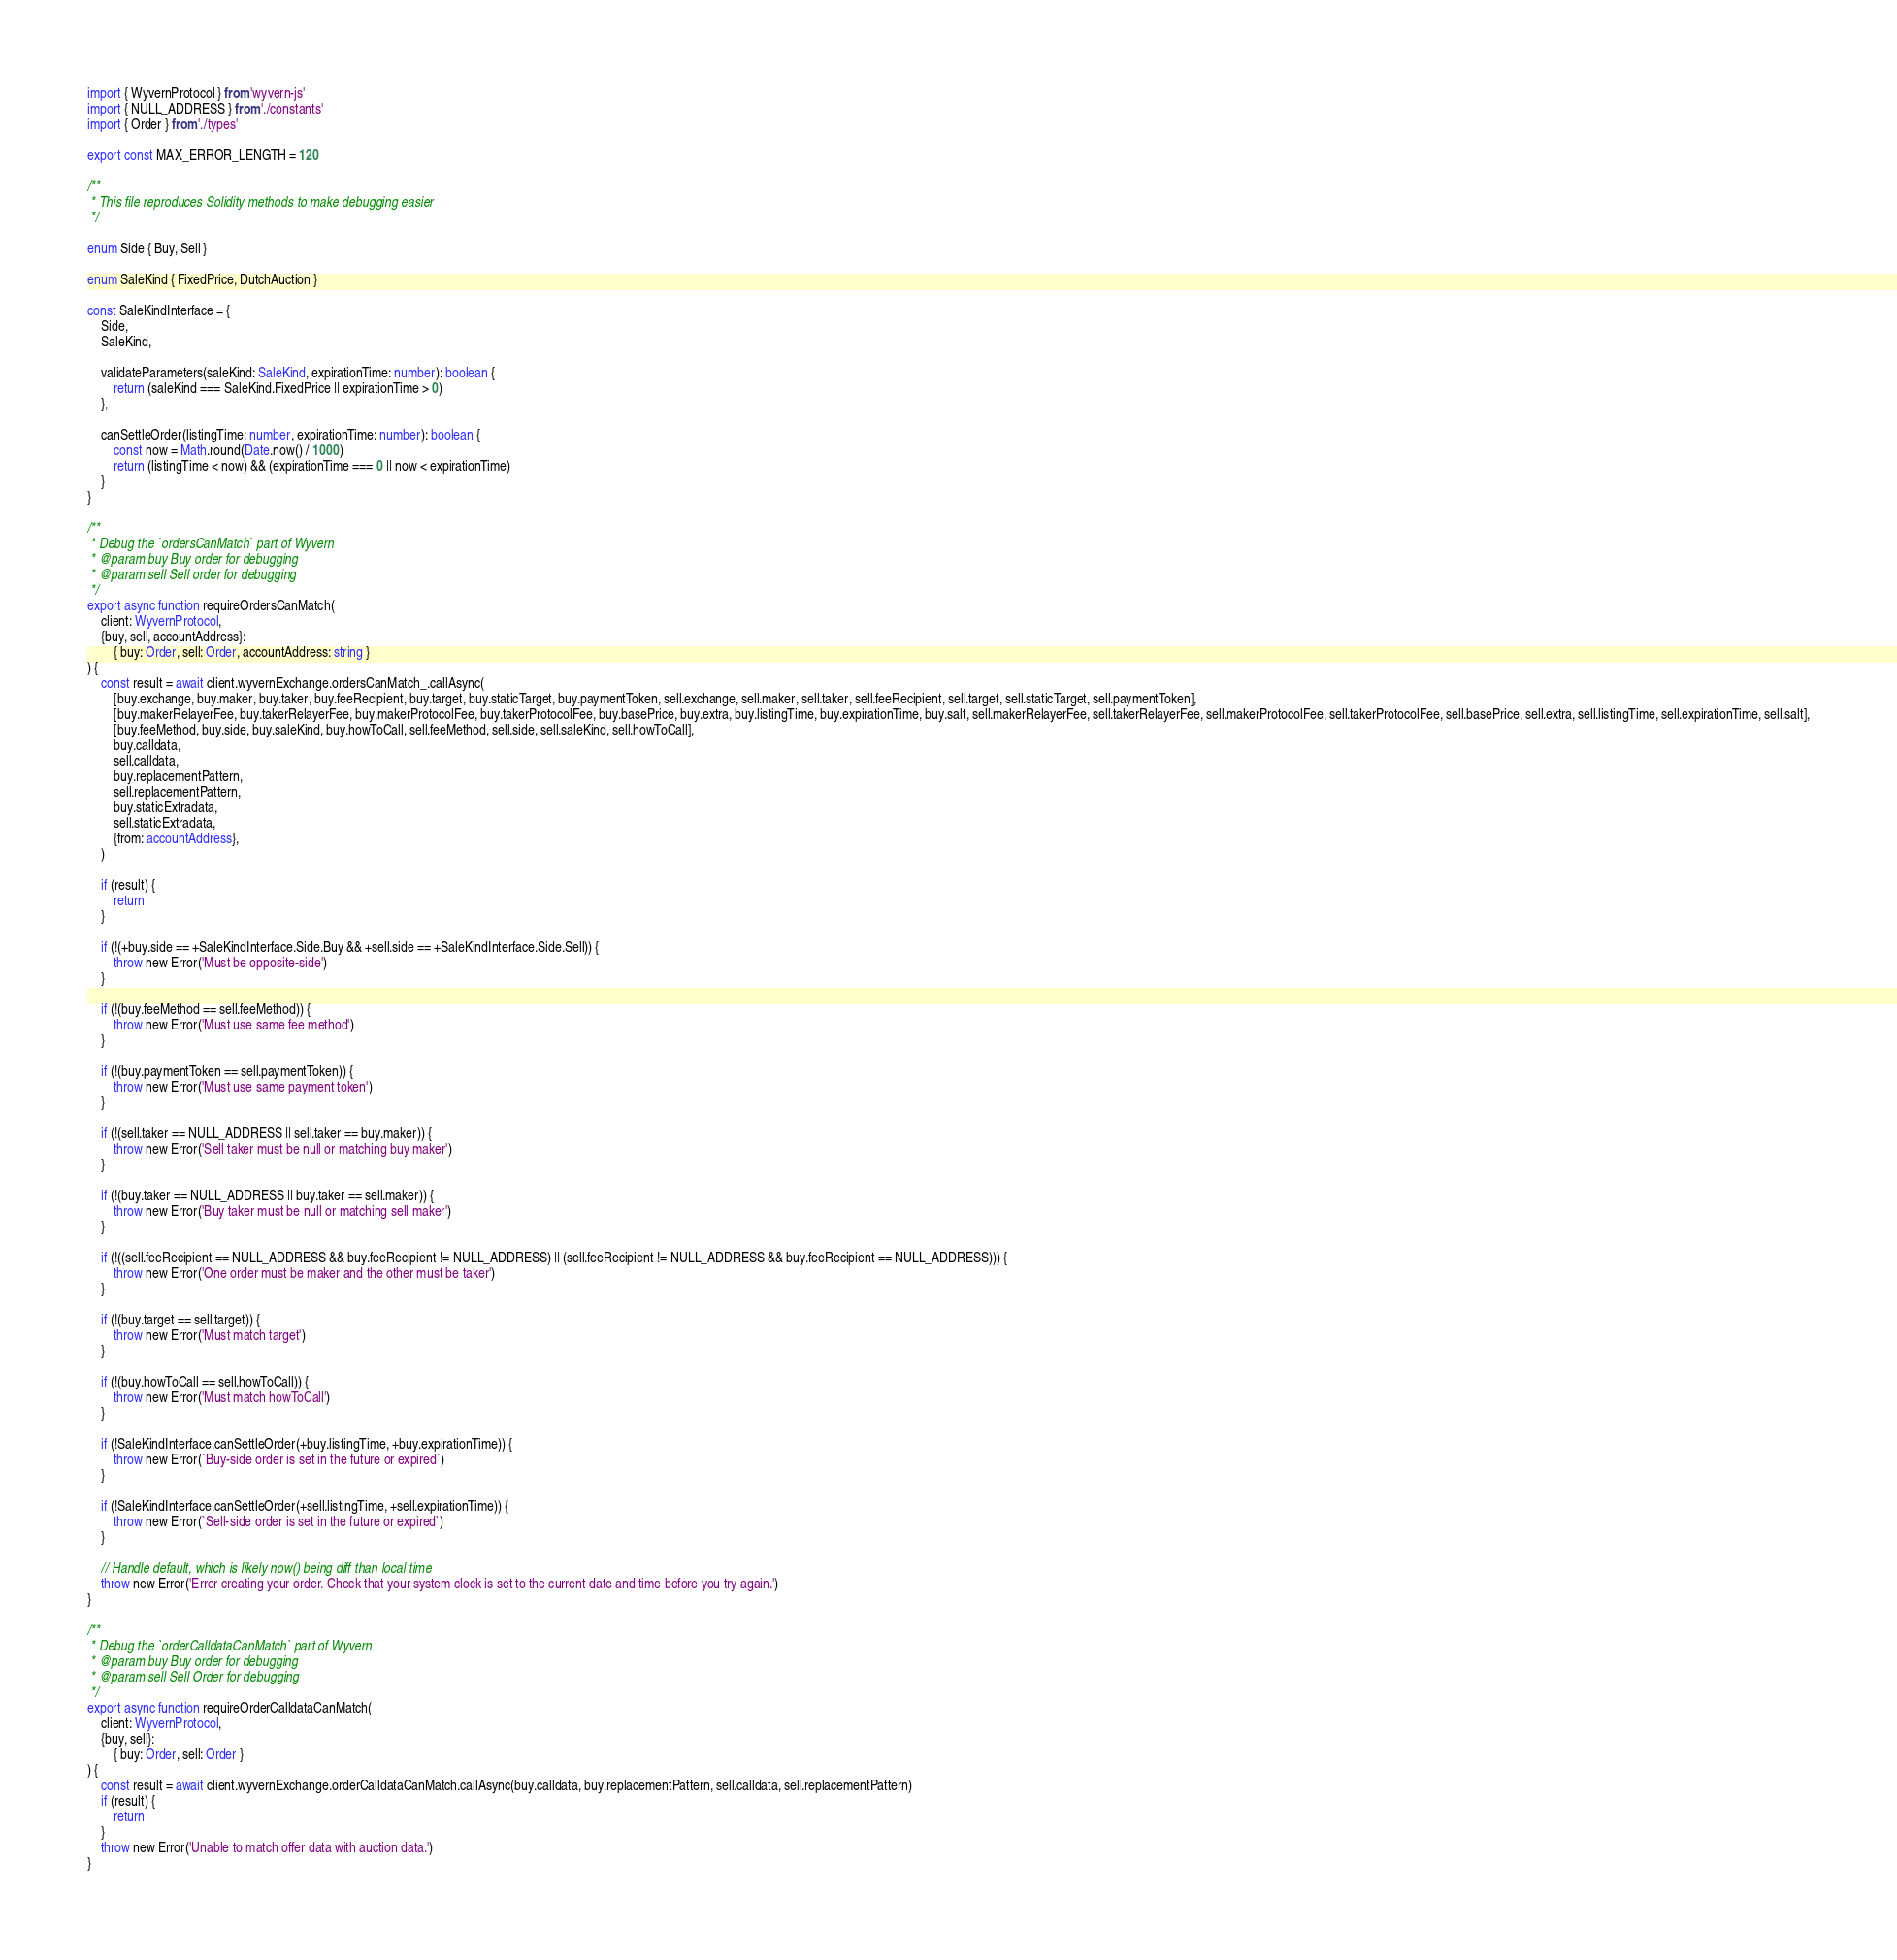Convert code to text. <code><loc_0><loc_0><loc_500><loc_500><_TypeScript_>import { WyvernProtocol } from 'wyvern-js'
import { NULL_ADDRESS } from './constants'
import { Order } from './types'

export const MAX_ERROR_LENGTH = 120

/**
 * This file reproduces Solidity methods to make debugging easier
 */

enum Side { Buy, Sell }

enum SaleKind { FixedPrice, DutchAuction }

const SaleKindInterface = {
    Side,
    SaleKind,

    validateParameters(saleKind: SaleKind, expirationTime: number): boolean {
        return (saleKind === SaleKind.FixedPrice || expirationTime > 0)
    },

    canSettleOrder(listingTime: number, expirationTime: number): boolean {
        const now = Math.round(Date.now() / 1000)
        return (listingTime < now) && (expirationTime === 0 || now < expirationTime)
    }
}

/**
 * Debug the `ordersCanMatch` part of Wyvern
 * @param buy Buy order for debugging
 * @param sell Sell order for debugging
 */
export async function requireOrdersCanMatch(
    client: WyvernProtocol,
    {buy, sell, accountAddress}:
        { buy: Order, sell: Order, accountAddress: string }
) {
    const result = await client.wyvernExchange.ordersCanMatch_.callAsync(
        [buy.exchange, buy.maker, buy.taker, buy.feeRecipient, buy.target, buy.staticTarget, buy.paymentToken, sell.exchange, sell.maker, sell.taker, sell.feeRecipient, sell.target, sell.staticTarget, sell.paymentToken],
        [buy.makerRelayerFee, buy.takerRelayerFee, buy.makerProtocolFee, buy.takerProtocolFee, buy.basePrice, buy.extra, buy.listingTime, buy.expirationTime, buy.salt, sell.makerRelayerFee, sell.takerRelayerFee, sell.makerProtocolFee, sell.takerProtocolFee, sell.basePrice, sell.extra, sell.listingTime, sell.expirationTime, sell.salt],
        [buy.feeMethod, buy.side, buy.saleKind, buy.howToCall, sell.feeMethod, sell.side, sell.saleKind, sell.howToCall],
        buy.calldata,
        sell.calldata,
        buy.replacementPattern,
        sell.replacementPattern,
        buy.staticExtradata,
        sell.staticExtradata,
        {from: accountAddress},
    )

    if (result) {
        return
    }

    if (!(+buy.side == +SaleKindInterface.Side.Buy && +sell.side == +SaleKindInterface.Side.Sell)) {
        throw new Error('Must be opposite-side')
    }

    if (!(buy.feeMethod == sell.feeMethod)) {
        throw new Error('Must use same fee method')
    }

    if (!(buy.paymentToken == sell.paymentToken)) {
        throw new Error('Must use same payment token')
    }

    if (!(sell.taker == NULL_ADDRESS || sell.taker == buy.maker)) {
        throw new Error('Sell taker must be null or matching buy maker')
    }

    if (!(buy.taker == NULL_ADDRESS || buy.taker == sell.maker)) {
        throw new Error('Buy taker must be null or matching sell maker')
    }

    if (!((sell.feeRecipient == NULL_ADDRESS && buy.feeRecipient != NULL_ADDRESS) || (sell.feeRecipient != NULL_ADDRESS && buy.feeRecipient == NULL_ADDRESS))) {
        throw new Error('One order must be maker and the other must be taker')
    }

    if (!(buy.target == sell.target)) {
        throw new Error('Must match target')
    }

    if (!(buy.howToCall == sell.howToCall)) {
        throw new Error('Must match howToCall')
    }

    if (!SaleKindInterface.canSettleOrder(+buy.listingTime, +buy.expirationTime)) {
        throw new Error(`Buy-side order is set in the future or expired`)
    }

    if (!SaleKindInterface.canSettleOrder(+sell.listingTime, +sell.expirationTime)) {
        throw new Error(`Sell-side order is set in the future or expired`)
    }

    // Handle default, which is likely now() being diff than local time
    throw new Error('Error creating your order. Check that your system clock is set to the current date and time before you try again.')
}

/**
 * Debug the `orderCalldataCanMatch` part of Wyvern
 * @param buy Buy order for debugging
 * @param sell Sell Order for debugging
 */
export async function requireOrderCalldataCanMatch(
    client: WyvernProtocol,
    {buy, sell}:
        { buy: Order, sell: Order }
) {
    const result = await client.wyvernExchange.orderCalldataCanMatch.callAsync(buy.calldata, buy.replacementPattern, sell.calldata, sell.replacementPattern)
    if (result) {
        return
    }
    throw new Error('Unable to match offer data with auction data.')
}
</code> 